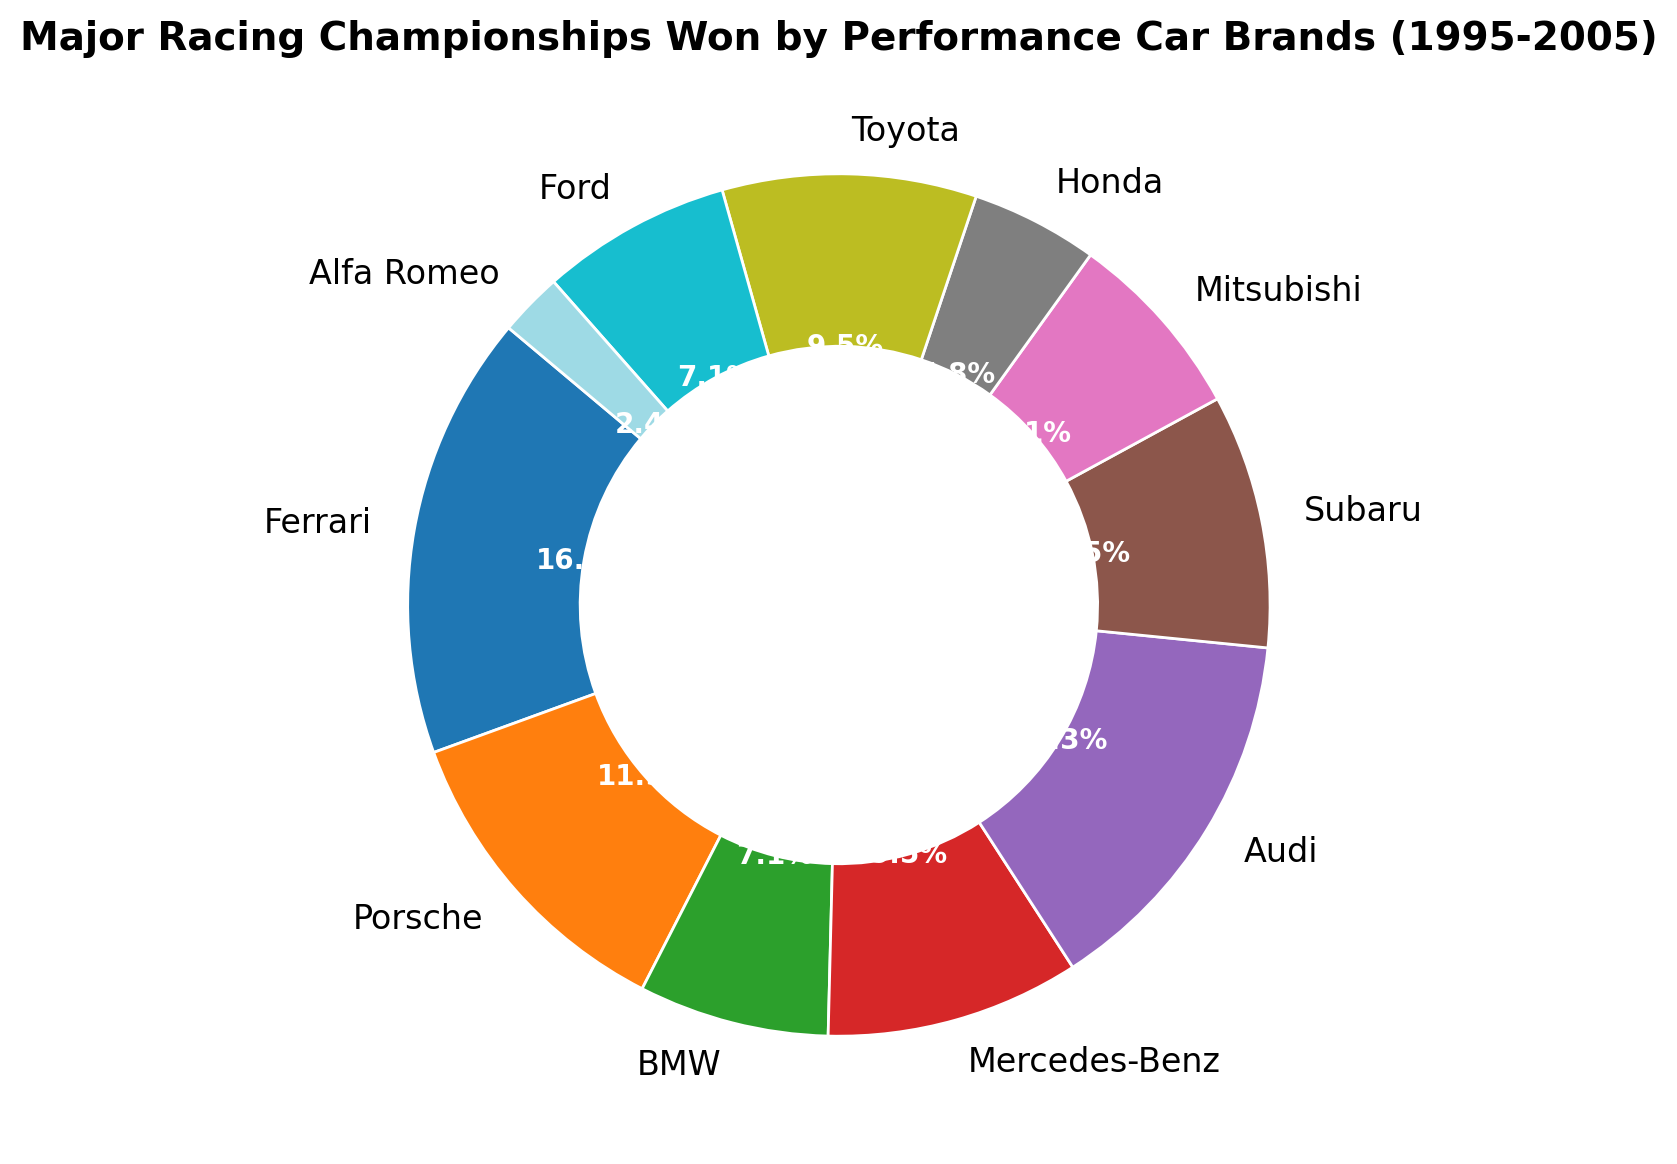What brand won the most championships? The brand with the largest segment in the ring chart represents the most championships won. Ferrari has the largest segment.
Answer: Ferrari How many more championships did Ferrari win compared to BMW? Ferrari won 7 championships and BMW won 3. The difference is calculated by subtracting BMW's championships from Ferrari's: 7 - 3 = 4.
Answer: 4 What's the combined total of championships won by Mercedes-Benz, Subaru, and Toyota? Add the championships won by each brand: Mercedes-Benz (4) + Subaru (4) + Toyota (4) = 12.
Answer: 12 Which brand has a larger share, Audi or Porsche? The ring chart shows that Audi’s segment is larger than Porsche’s, indicating a higher number of championships won. Audi won 6, while Porsche won 5.
Answer: Audi What is the average number of championships won by Mitsubishi, Honda, and Alfa Romeo? Add the championships won by each brand and then divide by the number of brands: (Mitsubishi 3 + Honda 2 + Alfa Romeo 1) / 3 = 2.
Answer: 2 List all the brands that won exactly 4 championships. Look for segments in the ring chart that correspond to 4 championships. The brands are Mercedes-Benz, Subaru, and Toyota.
Answer: Mercedes-Benz, Subaru, Toyota Did any brand win only one championship? Identify the segment in the ring chart with the smallest value, which is 1. Alfa Romeo is the brand.
Answer: Alfa Romeo How many championships were won in total? Add up the championships won by all the brands: 7+5+3+4+6+4+3+2+4+3+1 = 42.
Answer: 42 Which brands have won fewer championships than Subaru? Compare the number of championships won by Subaru (4) with other brands. Brands with fewer championships are BMW (3), Mitsubishi (3), Honda (2), Ford (3), and Alfa Romeo (1).
Answer: BMW, Mitsubishi, Honda, Ford, Alfa Romeo If you combine the championships won by Porsche and Ford, do they match the number won by Audi? Add up the championships won by Porsche and Ford, and compare with Audi. Porsche (5) + Ford (3) = 8; Audi won 6 championships.
Answer: No, they exceed Audi's count 